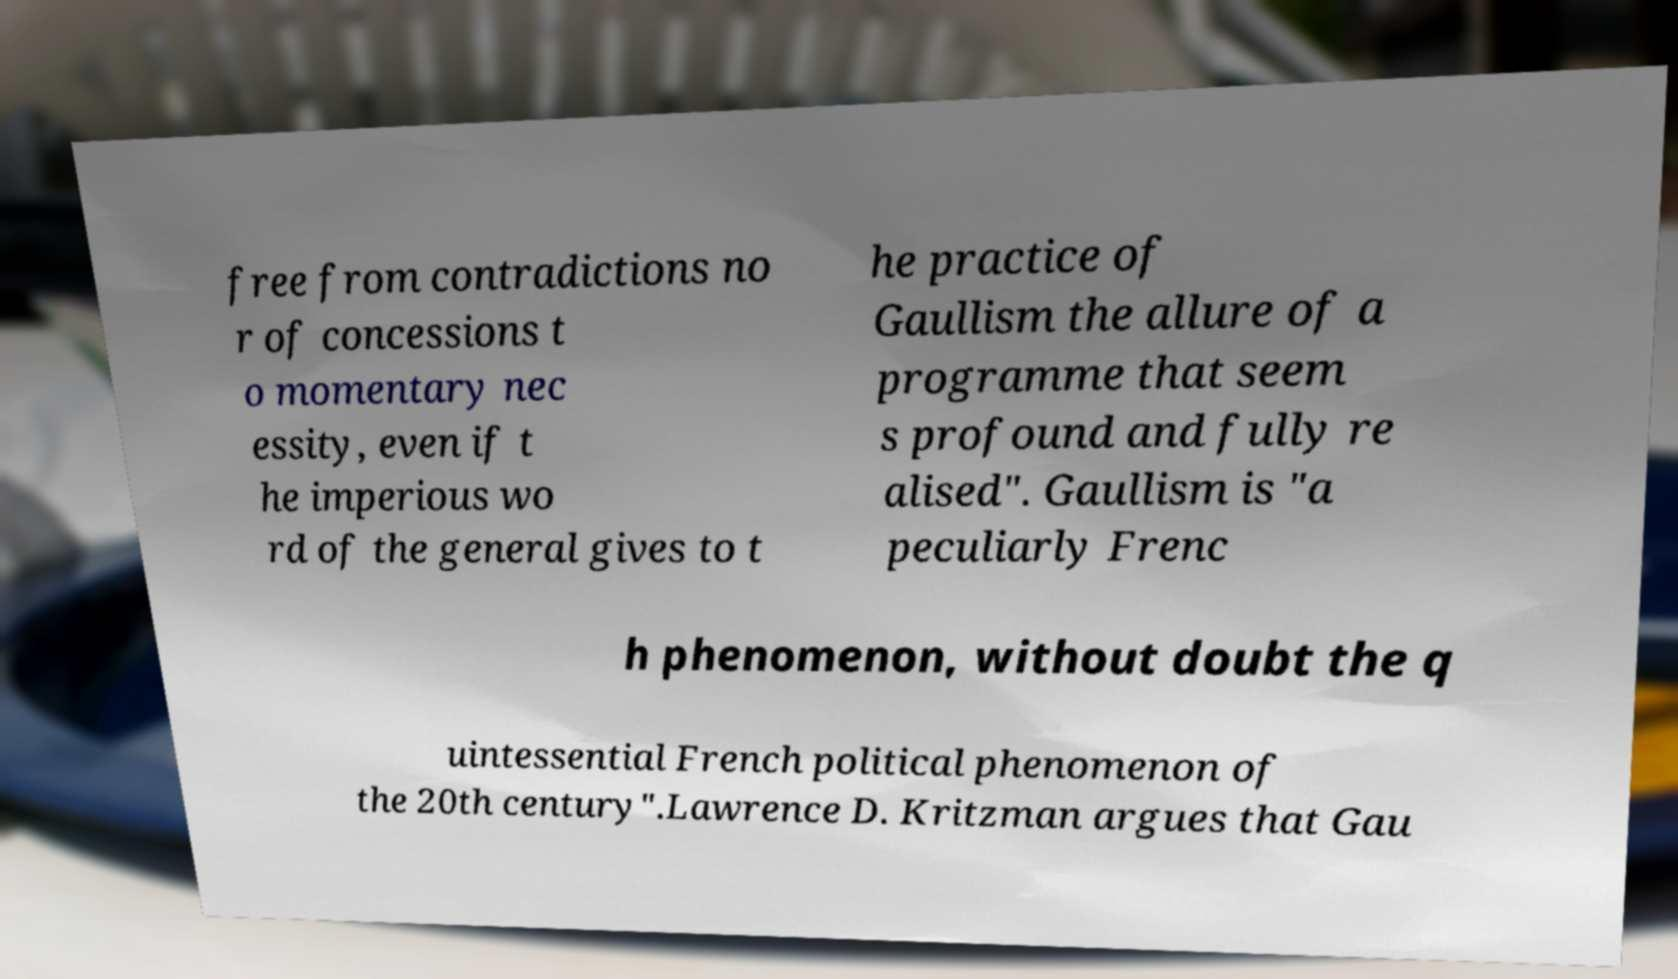Could you extract and type out the text from this image? free from contradictions no r of concessions t o momentary nec essity, even if t he imperious wo rd of the general gives to t he practice of Gaullism the allure of a programme that seem s profound and fully re alised". Gaullism is "a peculiarly Frenc h phenomenon, without doubt the q uintessential French political phenomenon of the 20th century".Lawrence D. Kritzman argues that Gau 